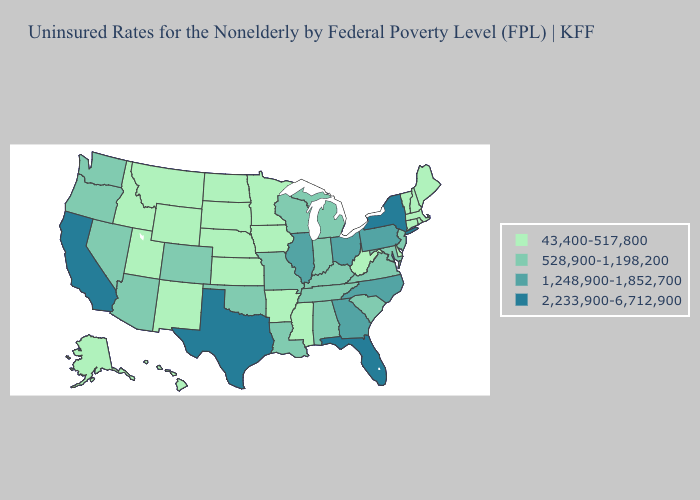Does the map have missing data?
Short answer required. No. Does Montana have the highest value in the West?
Answer briefly. No. Does New York have the highest value in the Northeast?
Write a very short answer. Yes. Which states have the lowest value in the MidWest?
Answer briefly. Iowa, Kansas, Minnesota, Nebraska, North Dakota, South Dakota. Does the first symbol in the legend represent the smallest category?
Write a very short answer. Yes. Which states hav the highest value in the South?
Keep it brief. Florida, Texas. What is the value of Vermont?
Be succinct. 43,400-517,800. What is the lowest value in the West?
Short answer required. 43,400-517,800. Name the states that have a value in the range 528,900-1,198,200?
Short answer required. Alabama, Arizona, Colorado, Indiana, Kentucky, Louisiana, Maryland, Michigan, Missouri, Nevada, New Jersey, Oklahoma, Oregon, South Carolina, Tennessee, Virginia, Washington, Wisconsin. Which states have the lowest value in the MidWest?
Answer briefly. Iowa, Kansas, Minnesota, Nebraska, North Dakota, South Dakota. Does the map have missing data?
Give a very brief answer. No. What is the lowest value in the USA?
Keep it brief. 43,400-517,800. Name the states that have a value in the range 43,400-517,800?
Keep it brief. Alaska, Arkansas, Connecticut, Delaware, Hawaii, Idaho, Iowa, Kansas, Maine, Massachusetts, Minnesota, Mississippi, Montana, Nebraska, New Hampshire, New Mexico, North Dakota, Rhode Island, South Dakota, Utah, Vermont, West Virginia, Wyoming. Name the states that have a value in the range 43,400-517,800?
Answer briefly. Alaska, Arkansas, Connecticut, Delaware, Hawaii, Idaho, Iowa, Kansas, Maine, Massachusetts, Minnesota, Mississippi, Montana, Nebraska, New Hampshire, New Mexico, North Dakota, Rhode Island, South Dakota, Utah, Vermont, West Virginia, Wyoming. Which states have the lowest value in the USA?
Give a very brief answer. Alaska, Arkansas, Connecticut, Delaware, Hawaii, Idaho, Iowa, Kansas, Maine, Massachusetts, Minnesota, Mississippi, Montana, Nebraska, New Hampshire, New Mexico, North Dakota, Rhode Island, South Dakota, Utah, Vermont, West Virginia, Wyoming. 